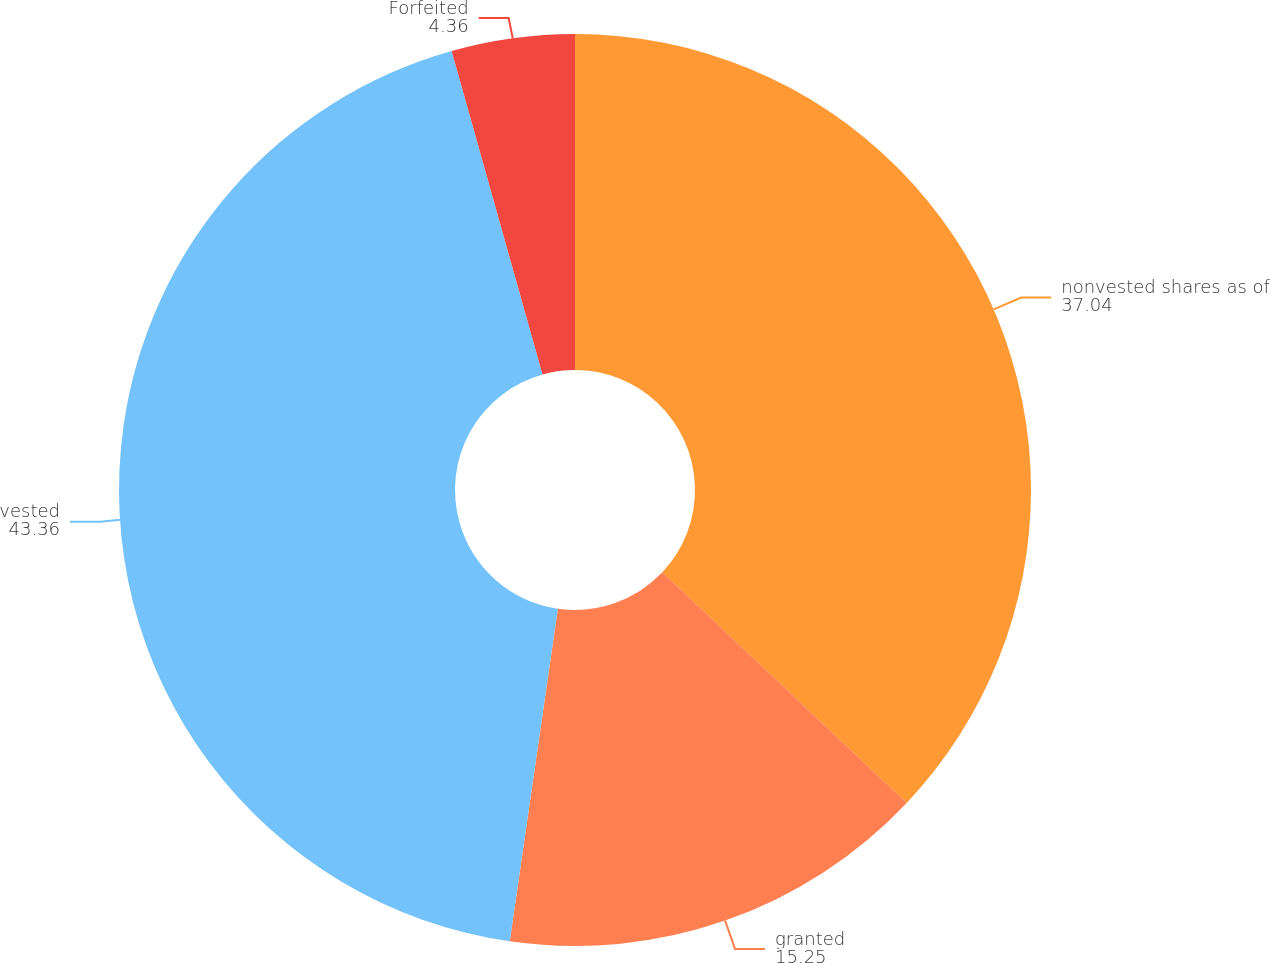Convert chart. <chart><loc_0><loc_0><loc_500><loc_500><pie_chart><fcel>nonvested shares as of<fcel>granted<fcel>vested<fcel>Forfeited<nl><fcel>37.04%<fcel>15.25%<fcel>43.36%<fcel>4.36%<nl></chart> 